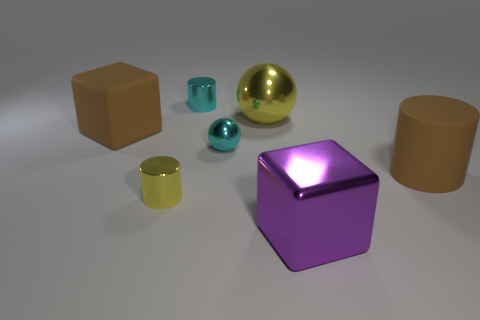Do the materials of the objects differ and how can you tell? Yes, the objects seem to be made of different materials. The large yellow sphere, the cyan smaller sphere, and the metallic teal tiny sphere have reflective surfaces, suggesting they could be made of polished metal or plastic. The purple cube also has a slightly reflective surface, but its texture also appears to be smooth like painted metal or plastic. The two blocks and the cylinder have matte finishes, indicating they could be made of a non-reflective material like wood or unpolished plastic.  Assuming these objects are related, what could be a common theme or purpose connecting them? If we're to speculate on a common theme, these objects might be part of a color and material study, demonstrating the interaction of light with different surface types and colors. Alternatively, they could be used as reference objects for 3D modeling and rendering exercises, considering their various geometric shapes and textures. 